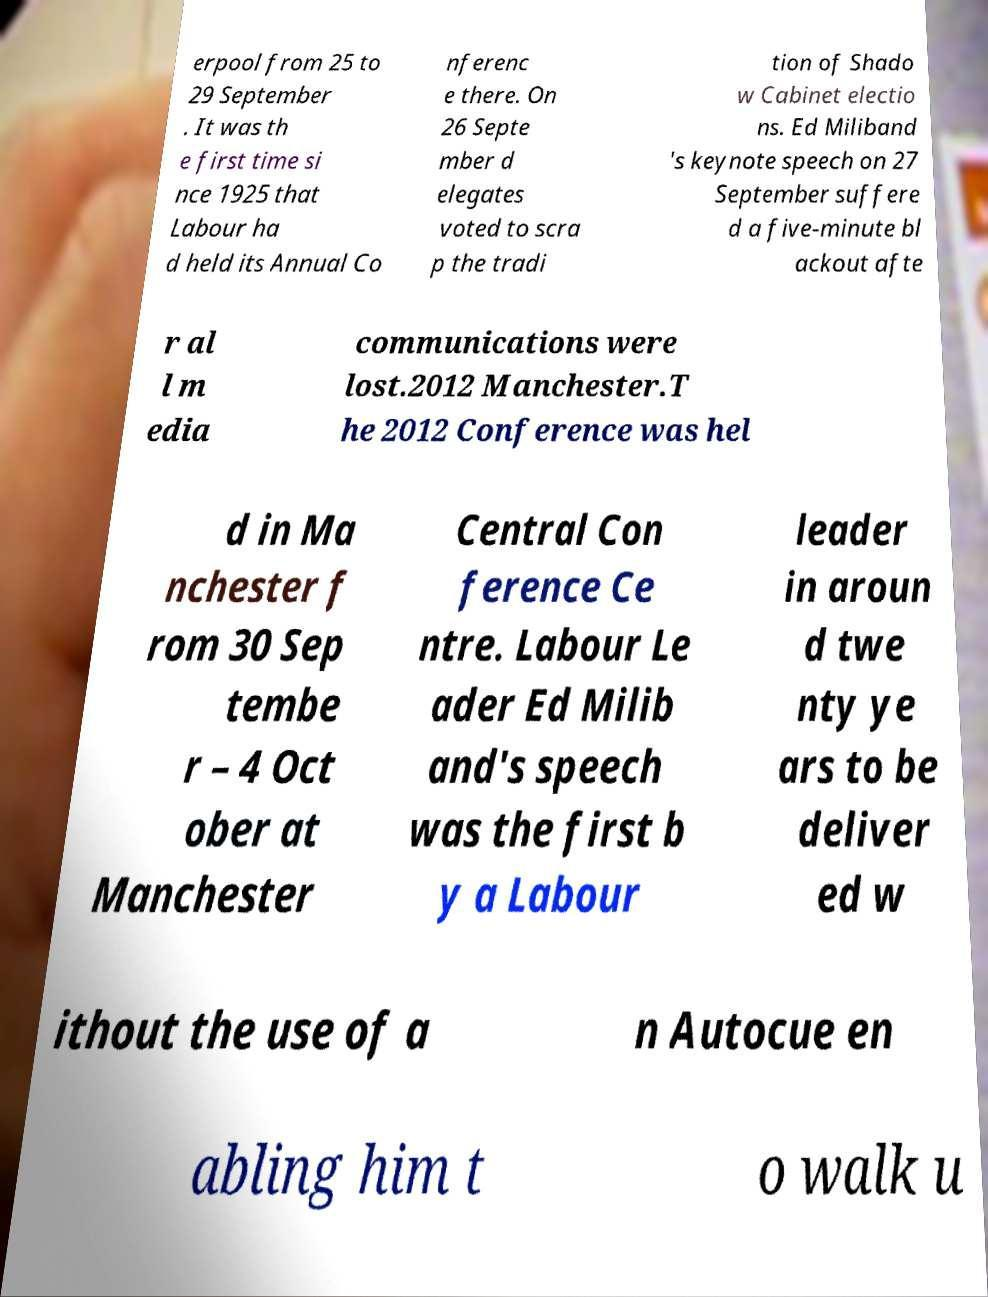For documentation purposes, I need the text within this image transcribed. Could you provide that? erpool from 25 to 29 September . It was th e first time si nce 1925 that Labour ha d held its Annual Co nferenc e there. On 26 Septe mber d elegates voted to scra p the tradi tion of Shado w Cabinet electio ns. Ed Miliband 's keynote speech on 27 September suffere d a five-minute bl ackout afte r al l m edia communications were lost.2012 Manchester.T he 2012 Conference was hel d in Ma nchester f rom 30 Sep tembe r – 4 Oct ober at Manchester Central Con ference Ce ntre. Labour Le ader Ed Milib and's speech was the first b y a Labour leader in aroun d twe nty ye ars to be deliver ed w ithout the use of a n Autocue en abling him t o walk u 